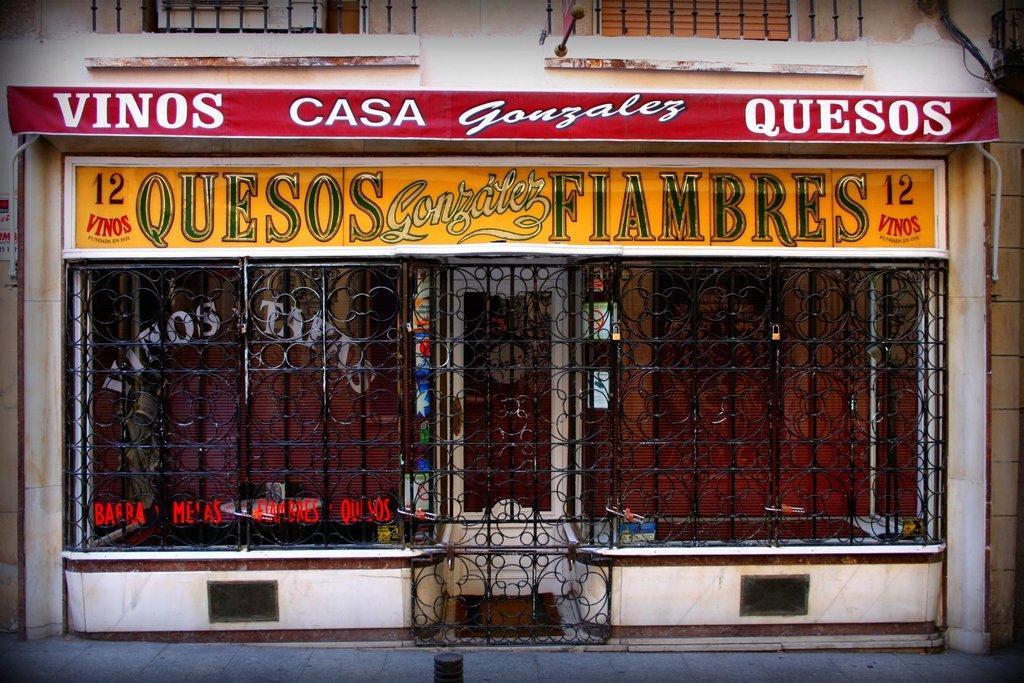Please provide a concise description of this image. In this image there is a grill and in the background there is a building and there are boards with some text written on it. 